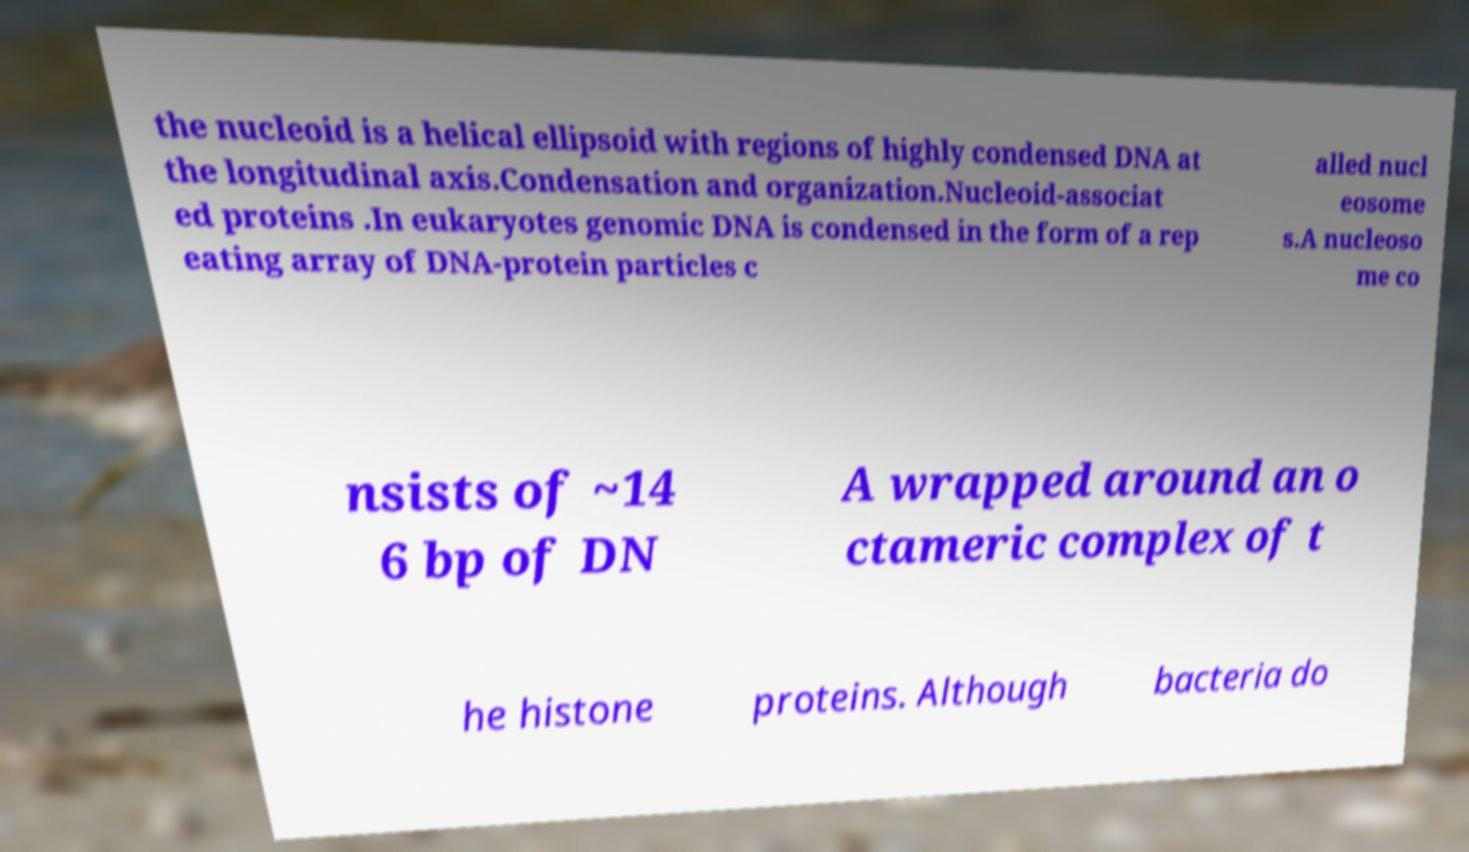I need the written content from this picture converted into text. Can you do that? the nucleoid is a helical ellipsoid with regions of highly condensed DNA at the longitudinal axis.Condensation and organization.Nucleoid-associat ed proteins .In eukaryotes genomic DNA is condensed in the form of a rep eating array of DNA-protein particles c alled nucl eosome s.A nucleoso me co nsists of ~14 6 bp of DN A wrapped around an o ctameric complex of t he histone proteins. Although bacteria do 